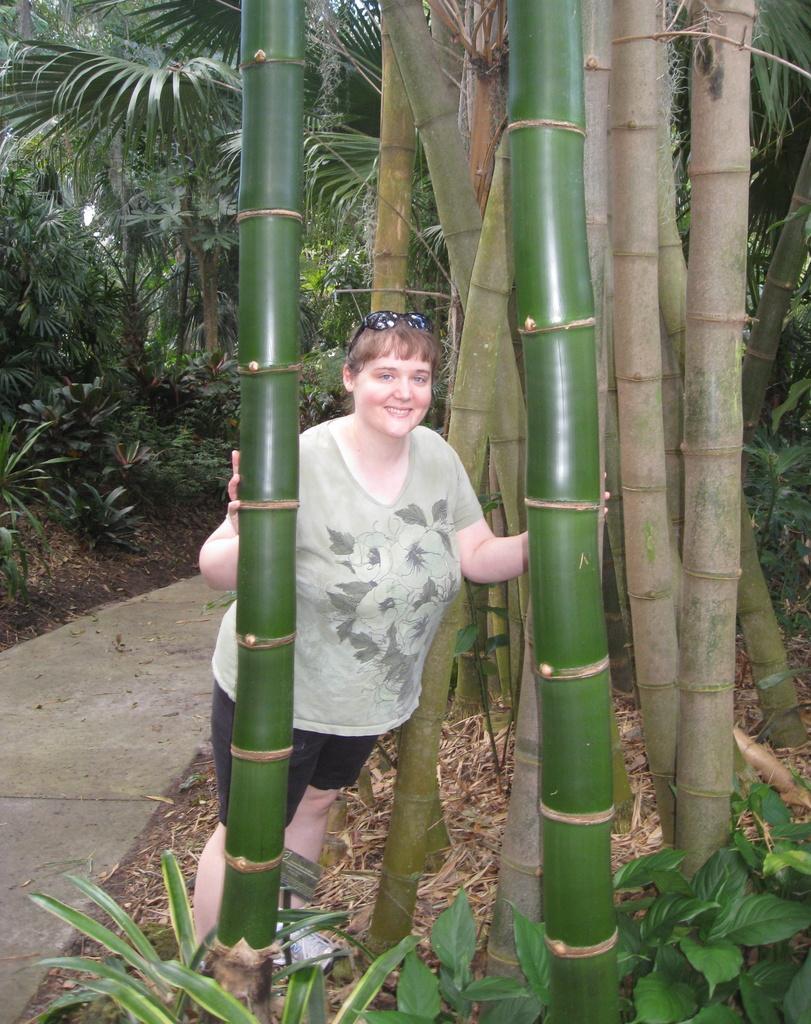Could you give a brief overview of what you see in this image? There is a woman standing and we can see plants and trees. In the background we can see trees. 